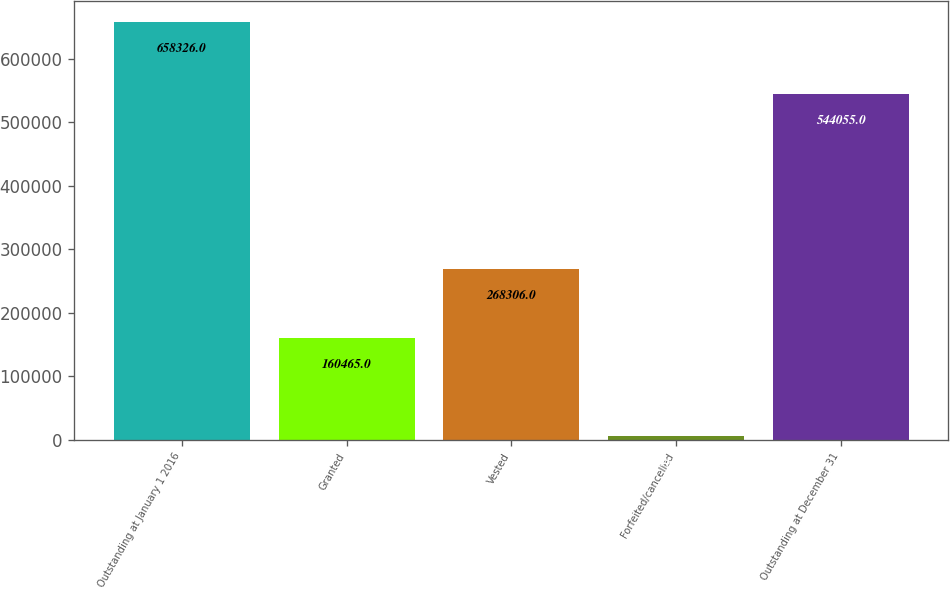<chart> <loc_0><loc_0><loc_500><loc_500><bar_chart><fcel>Outstanding at January 1 2016<fcel>Granted<fcel>Vested<fcel>Forfeited/cancelled<fcel>Outstanding at December 31<nl><fcel>658326<fcel>160465<fcel>268306<fcel>6430<fcel>544055<nl></chart> 